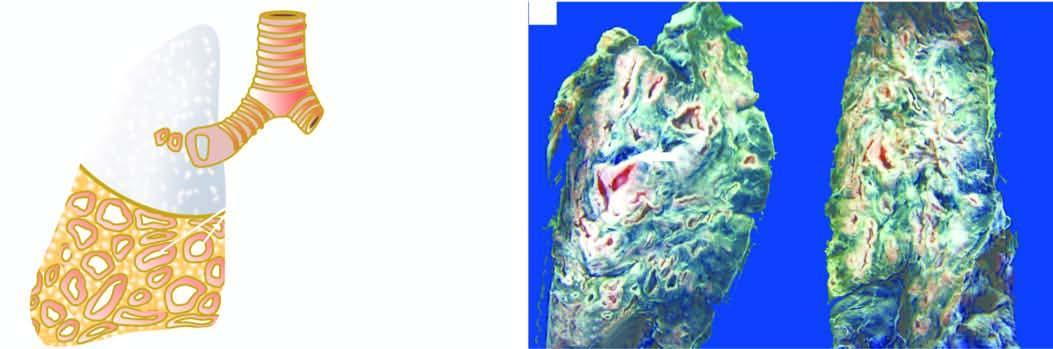what are seen?
Answer the question using a single word or phrase. Thick-walled dilated cavities with cartilaginous wall 